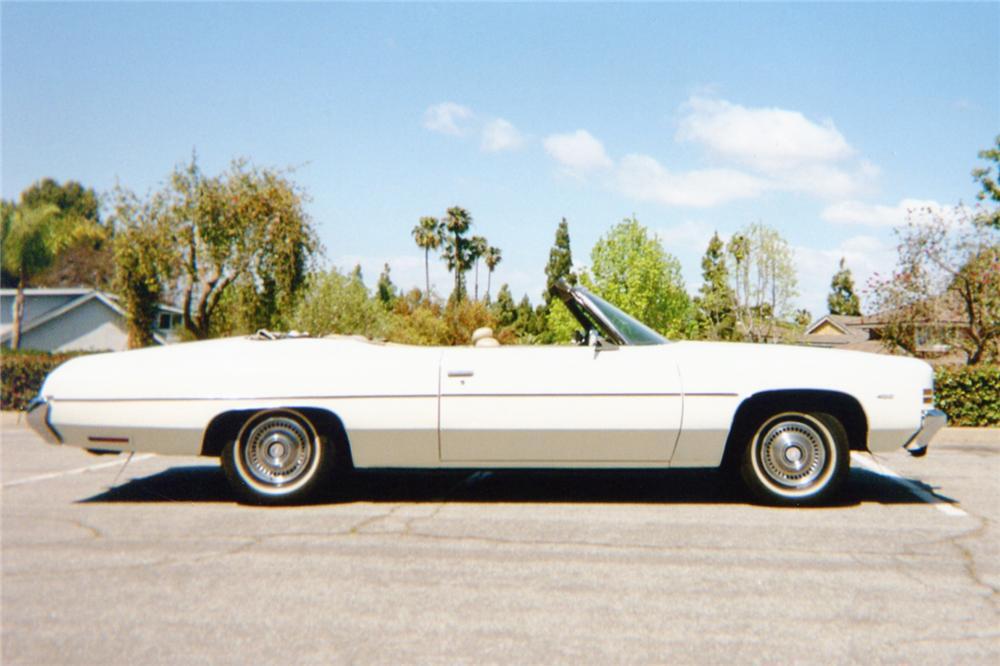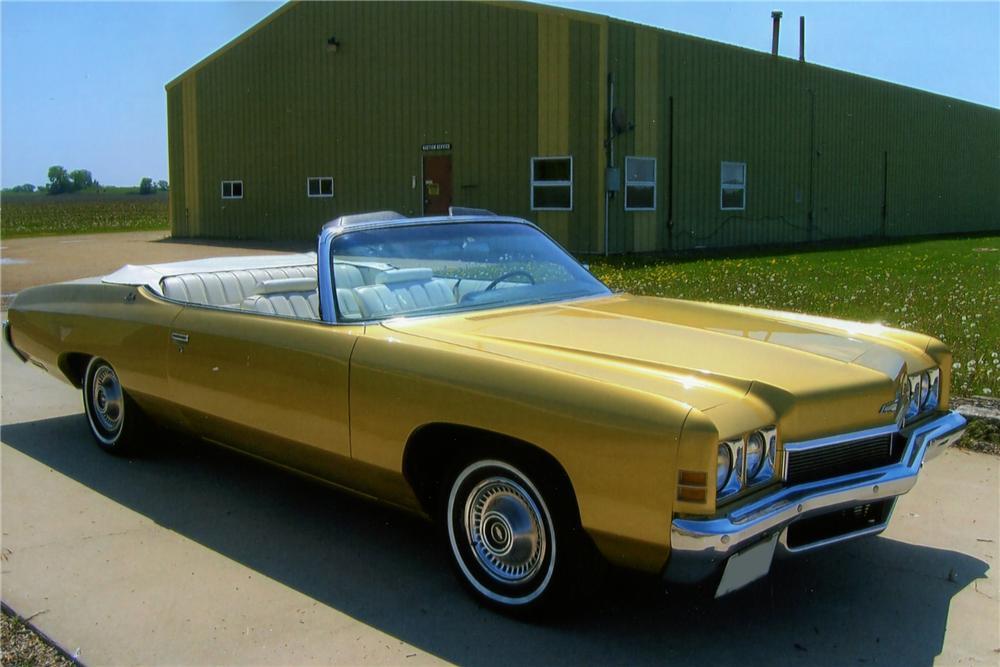The first image is the image on the left, the second image is the image on the right. Evaluate the accuracy of this statement regarding the images: "An image shows a convertible car covered with a dark top.". Is it true? Answer yes or no. No. The first image is the image on the left, the second image is the image on the right. Given the left and right images, does the statement "One or more of the cars shown are turned to the right." hold true? Answer yes or no. Yes. 